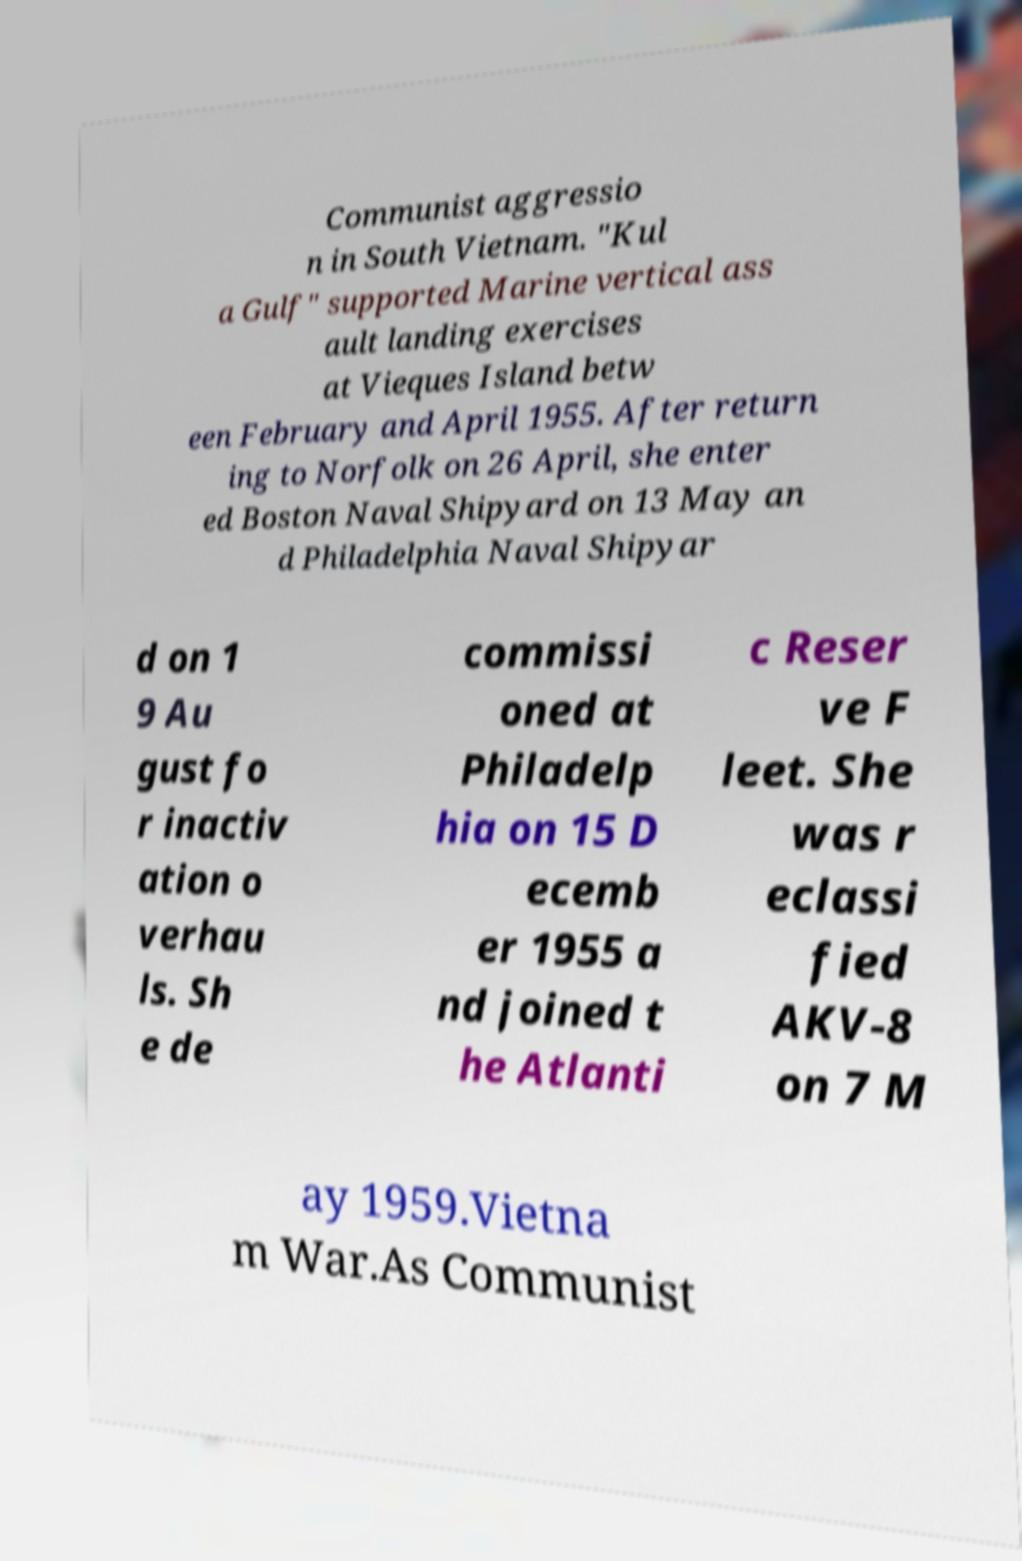Could you assist in decoding the text presented in this image and type it out clearly? Communist aggressio n in South Vietnam. "Kul a Gulf" supported Marine vertical ass ault landing exercises at Vieques Island betw een February and April 1955. After return ing to Norfolk on 26 April, she enter ed Boston Naval Shipyard on 13 May an d Philadelphia Naval Shipyar d on 1 9 Au gust fo r inactiv ation o verhau ls. Sh e de commissi oned at Philadelp hia on 15 D ecemb er 1955 a nd joined t he Atlanti c Reser ve F leet. She was r eclassi fied AKV-8 on 7 M ay 1959.Vietna m War.As Communist 